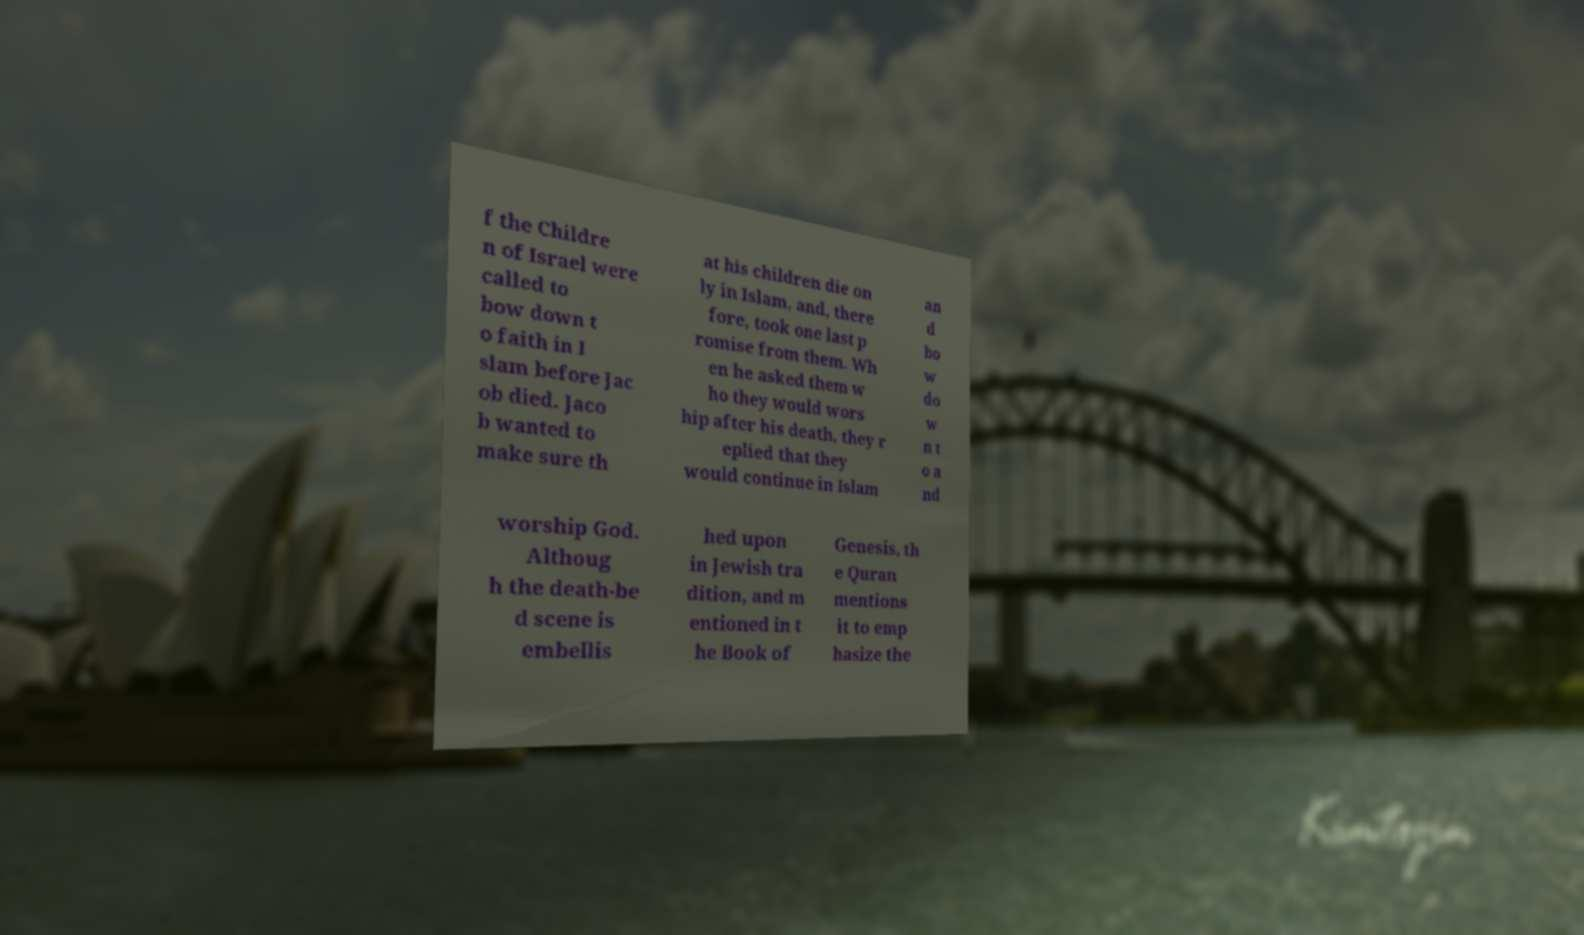I need the written content from this picture converted into text. Can you do that? f the Childre n of Israel were called to bow down t o faith in I slam before Jac ob died. Jaco b wanted to make sure th at his children die on ly in Islam, and, there fore, took one last p romise from them. Wh en he asked them w ho they would wors hip after his death, they r eplied that they would continue in Islam an d bo w do w n t o a nd worship God. Althoug h the death-be d scene is embellis hed upon in Jewish tra dition, and m entioned in t he Book of Genesis, th e Quran mentions it to emp hasize the 